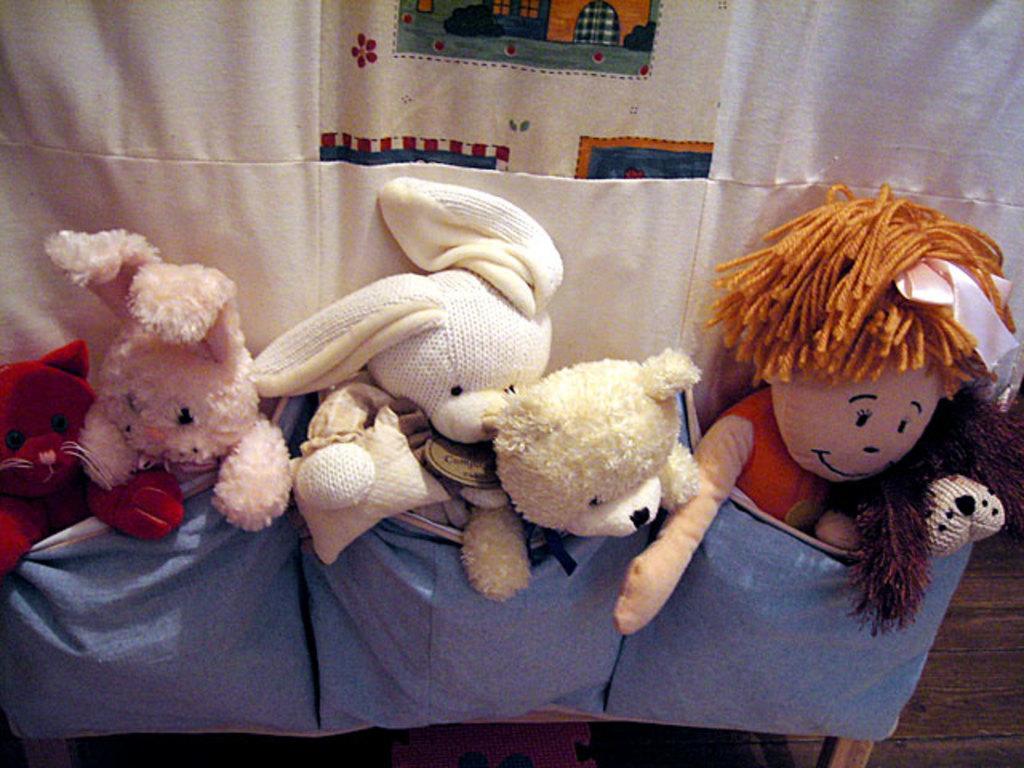How would you summarize this image in a sentence or two? In this picture I can see toys in the pockets of white color cloth. 